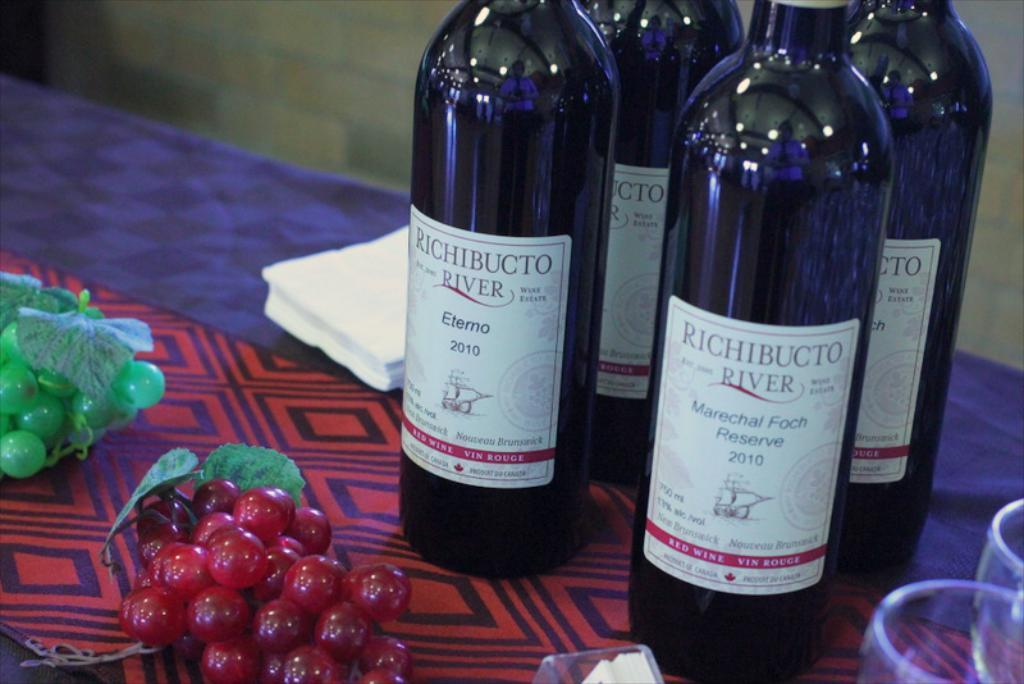<image>
Offer a succinct explanation of the picture presented. A bottle of Richibcto River Marechal Foch Reserve fro 2010 sits on a tablecloth next to a bottle of Eterno from 2010, with grapes in the foreground. 